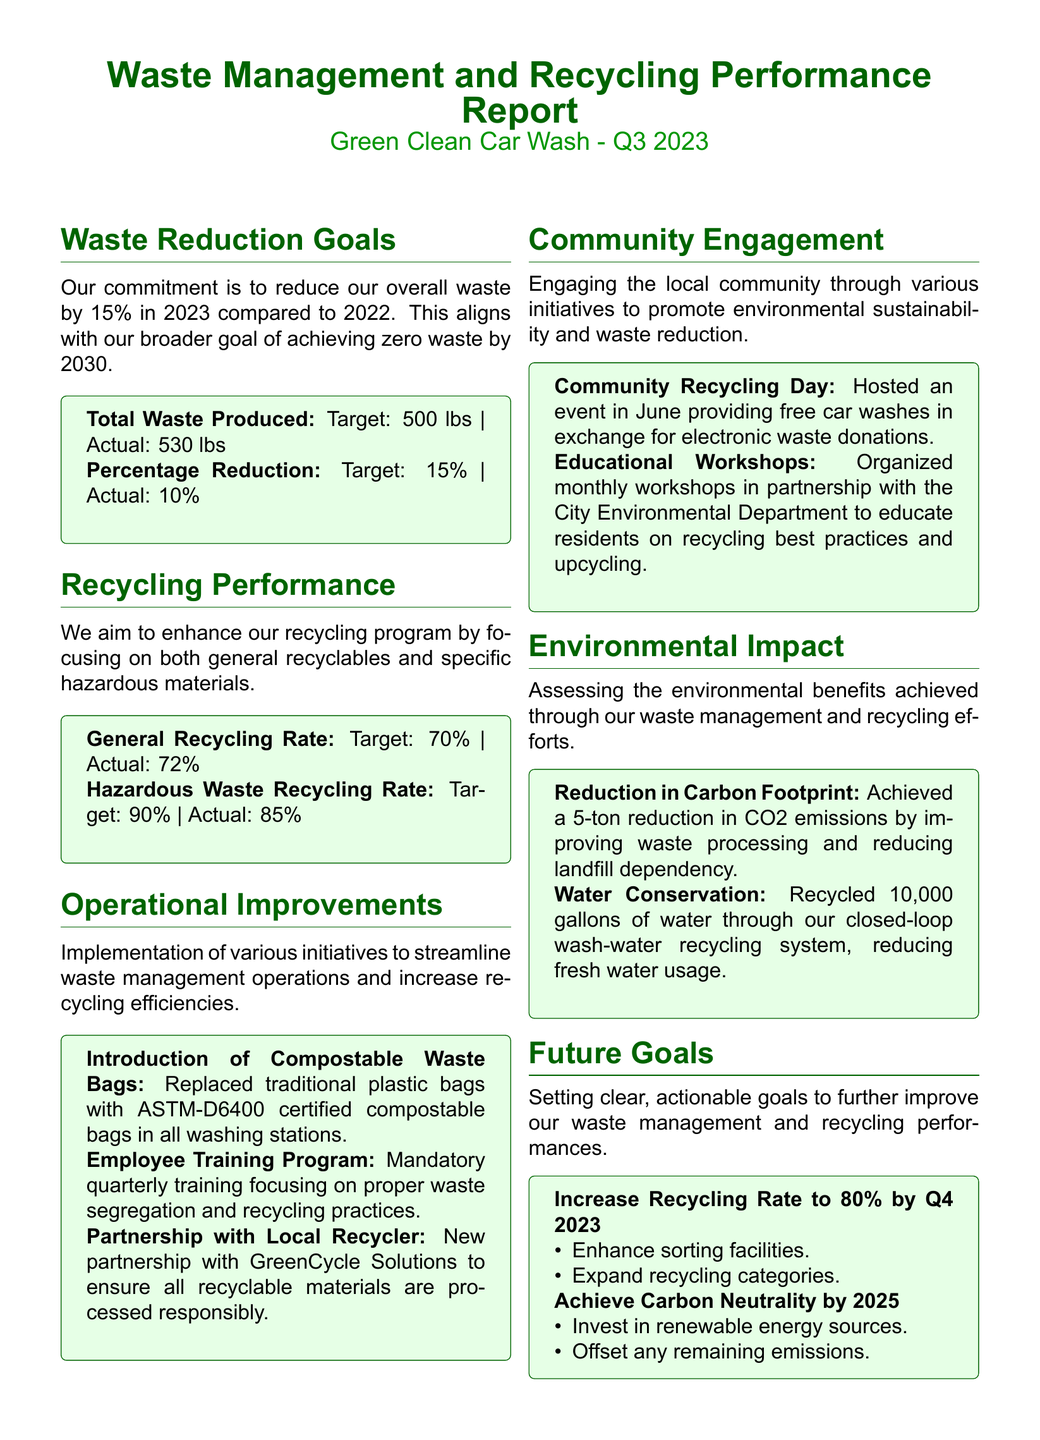What is the target percentage reduction for waste in 2023? The target percentage reduction for waste is specified as part of the waste reduction goals.
Answer: 15% What was the actual amount of total waste produced? The actual amount of total waste produced is listed alongside the target in the waste reduction section.
Answer: 530 lbs What is the general recycling rate achieved? The general recycling rate achieved is noted in the recycling performance section of the document.
Answer: 72% What is the hazardous waste recycling rate target? The hazardous waste recycling rate target is specified in the recycling performance section.
Answer: 90% What initiative replaced traditional plastic bags? The initiative that replaced traditional plastic bags is listed under operational improvements.
Answer: Compostable Waste Bags What event was hosted to engage the local community? The event designed to engage the community is documented under community engagement initiatives.
Answer: Community Recycling Day How many gallons of water were recycled through the closed-loop system? The amount of water recycled is specified in the environmental impact section of the report.
Answer: 10,000 gallons What is the goal for increasing the recycling rate by Q4 2023? The goal for increasing the recycling rate is stated explicitly under future goals in the report.
Answer: 80% What year is the target for achieving carbon neutrality? The target year for achieving carbon neutrality is mentioned in the future goals section.
Answer: 2025 